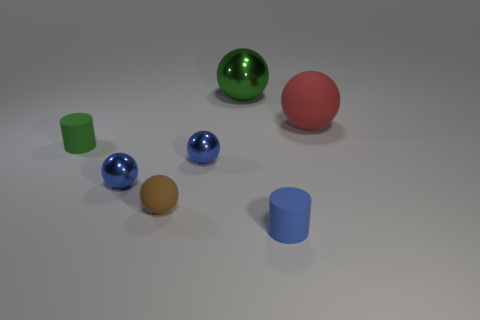Subtract 1 balls. How many balls are left? 4 Subtract all purple spheres. Subtract all red cubes. How many spheres are left? 5 Add 1 big green balls. How many objects exist? 8 Subtract all cylinders. How many objects are left? 5 Add 4 small green matte things. How many small green matte things are left? 5 Add 4 gray matte cubes. How many gray matte cubes exist? 4 Subtract 0 purple cubes. How many objects are left? 7 Subtract all small blue matte cylinders. Subtract all small things. How many objects are left? 1 